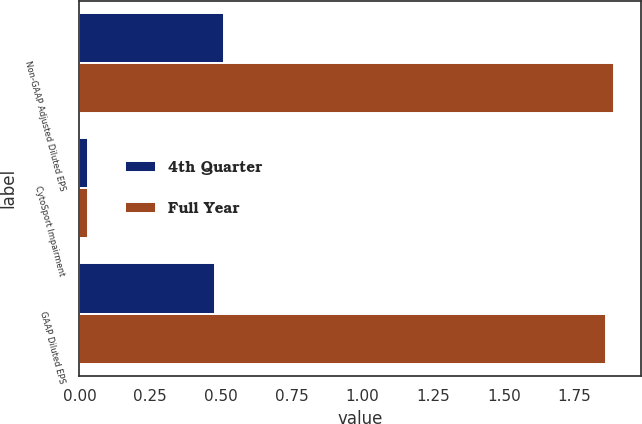Convert chart to OTSL. <chart><loc_0><loc_0><loc_500><loc_500><stacked_bar_chart><ecel><fcel>Non-GAAP Adjusted Diluted EPS<fcel>CytoSport Impairment<fcel>GAAP Diluted EPS<nl><fcel>4th Quarter<fcel>0.51<fcel>0.03<fcel>0.48<nl><fcel>Full Year<fcel>1.89<fcel>0.03<fcel>1.86<nl></chart> 